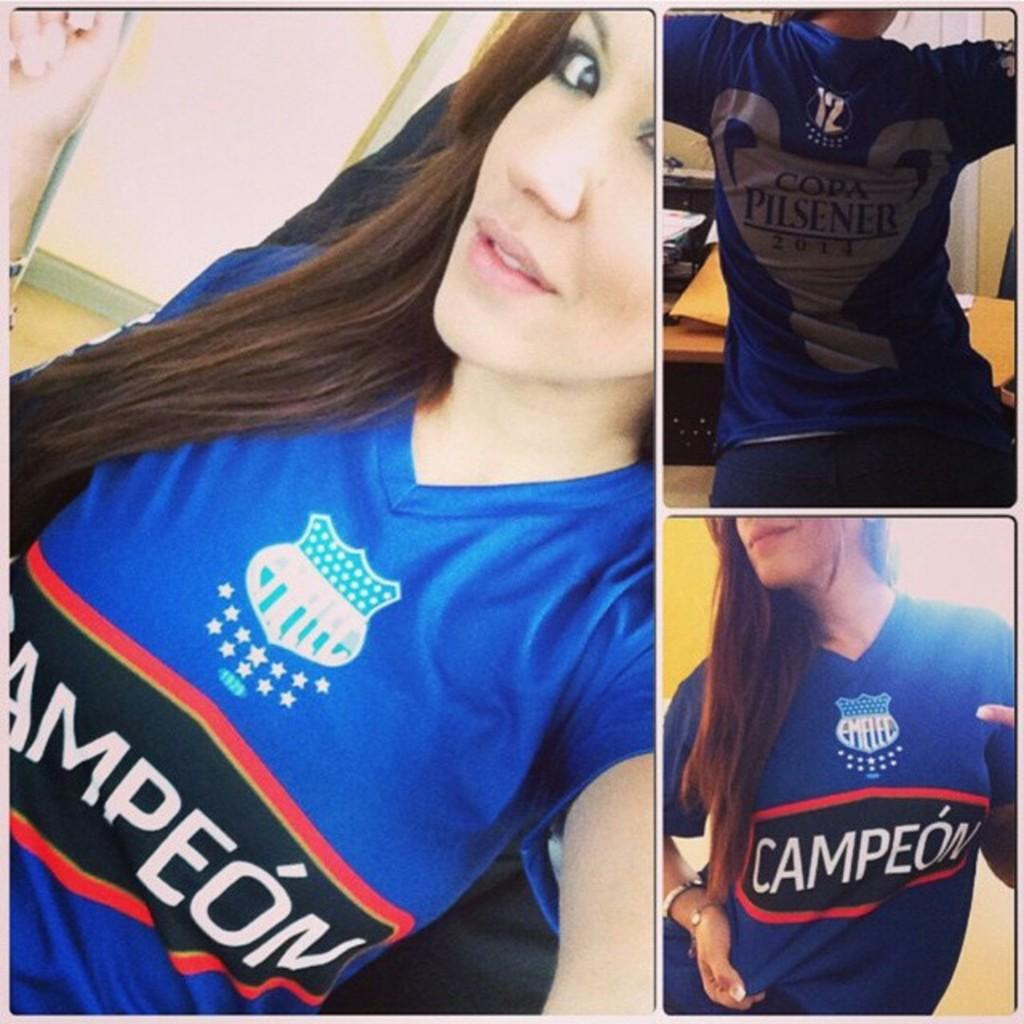<image>
Offer a succinct explanation of the picture presented. a girl with a Campeon shirt on that is blue 